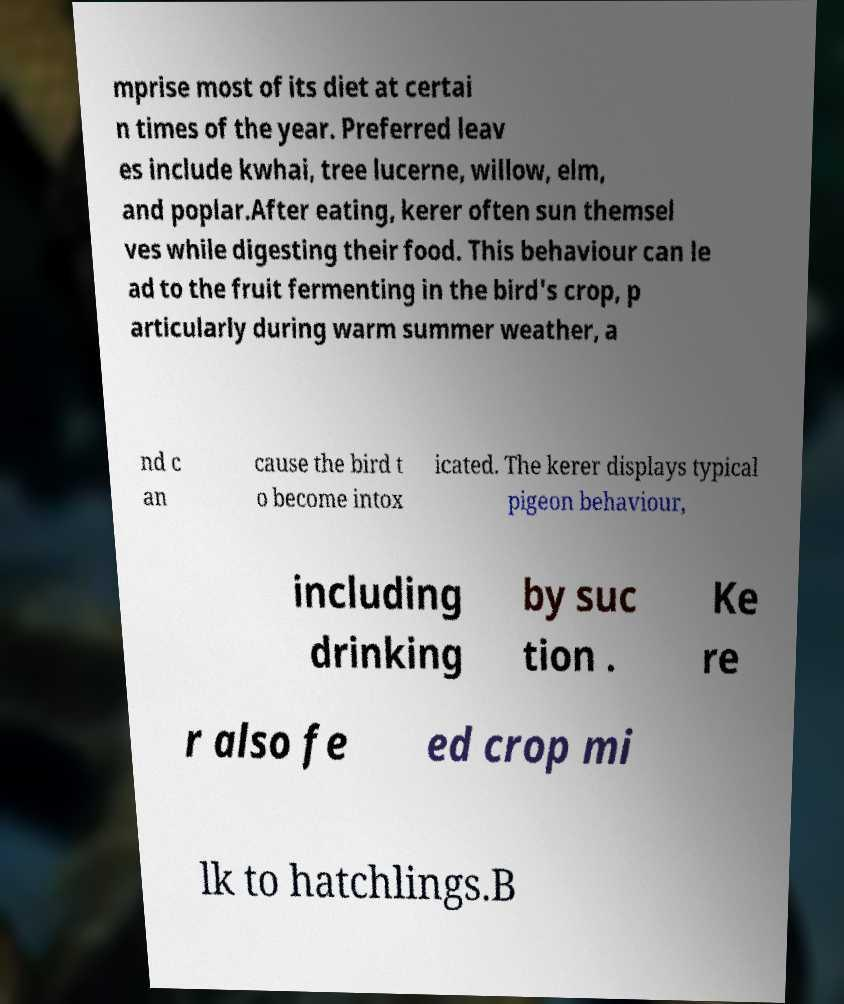What messages or text are displayed in this image? I need them in a readable, typed format. mprise most of its diet at certai n times of the year. Preferred leav es include kwhai, tree lucerne, willow, elm, and poplar.After eating, kerer often sun themsel ves while digesting their food. This behaviour can le ad to the fruit fermenting in the bird's crop, p articularly during warm summer weather, a nd c an cause the bird t o become intox icated. The kerer displays typical pigeon behaviour, including drinking by suc tion . Ke re r also fe ed crop mi lk to hatchlings.B 